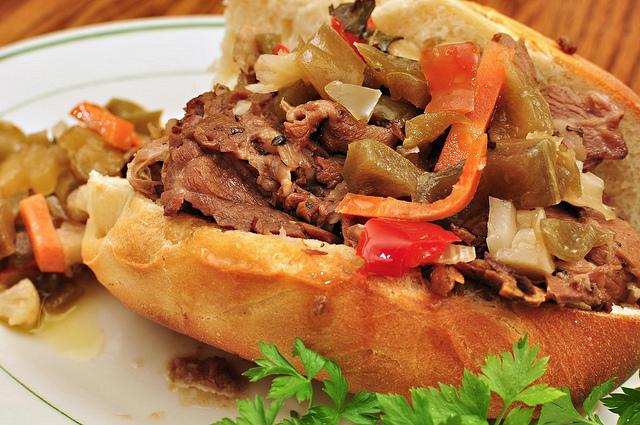Is this a chicken sandwich?
Quick response, please. No. What is the plate on?
Concise answer only. Table. What kind of sandwich is this?
Give a very brief answer. Steak. Could the garnish be cilantro?
Be succinct. Yes. Does the sandwich looks yummy?
Write a very short answer. Yes. Is there any peppers on this sandwich?
Be succinct. Yes. 